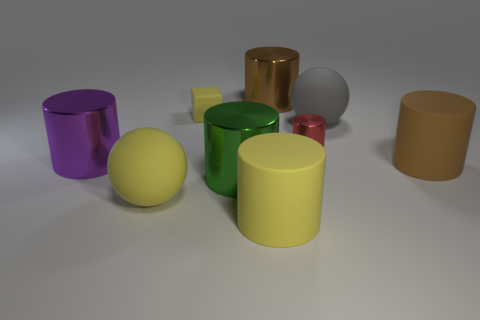Is the material of the big brown cylinder that is on the left side of the gray rubber ball the same as the yellow object that is behind the brown matte object? The big brown cylinder on the left side of the gray rubber ball appears to have a glossy finish, similar to the yellow cylinder behind the brown matte object. Both share a reflective quality indicative of a material that could be plastic or metal with a glossy coating. Without further information on the specific materials, it's challenging to confirm if they are indeed the same, but visually, they share a reflective characteristic. 